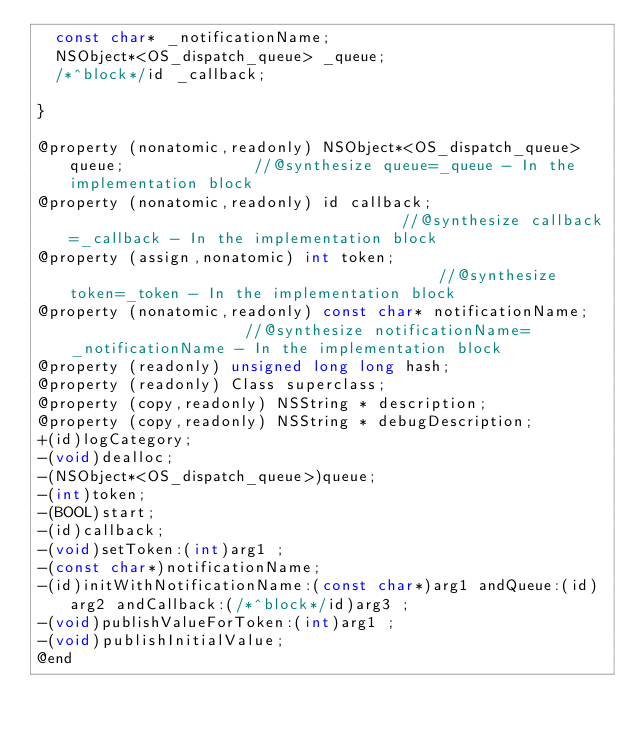Convert code to text. <code><loc_0><loc_0><loc_500><loc_500><_C_>	const char* _notificationName;
	NSObject*<OS_dispatch_queue> _queue;
	/*^block*/id _callback;

}

@property (nonatomic,readonly) NSObject*<OS_dispatch_queue> queue;              //@synthesize queue=_queue - In the implementation block
@property (nonatomic,readonly) id callback;                                     //@synthesize callback=_callback - In the implementation block
@property (assign,nonatomic) int token;                                         //@synthesize token=_token - In the implementation block
@property (nonatomic,readonly) const char* notificationName;                    //@synthesize notificationName=_notificationName - In the implementation block
@property (readonly) unsigned long long hash; 
@property (readonly) Class superclass; 
@property (copy,readonly) NSString * description; 
@property (copy,readonly) NSString * debugDescription; 
+(id)logCategory;
-(void)dealloc;
-(NSObject*<OS_dispatch_queue>)queue;
-(int)token;
-(BOOL)start;
-(id)callback;
-(void)setToken:(int)arg1 ;
-(const char*)notificationName;
-(id)initWithNotificationName:(const char*)arg1 andQueue:(id)arg2 andCallback:(/*^block*/id)arg3 ;
-(void)publishValueForToken:(int)arg1 ;
-(void)publishInitialValue;
@end

</code> 